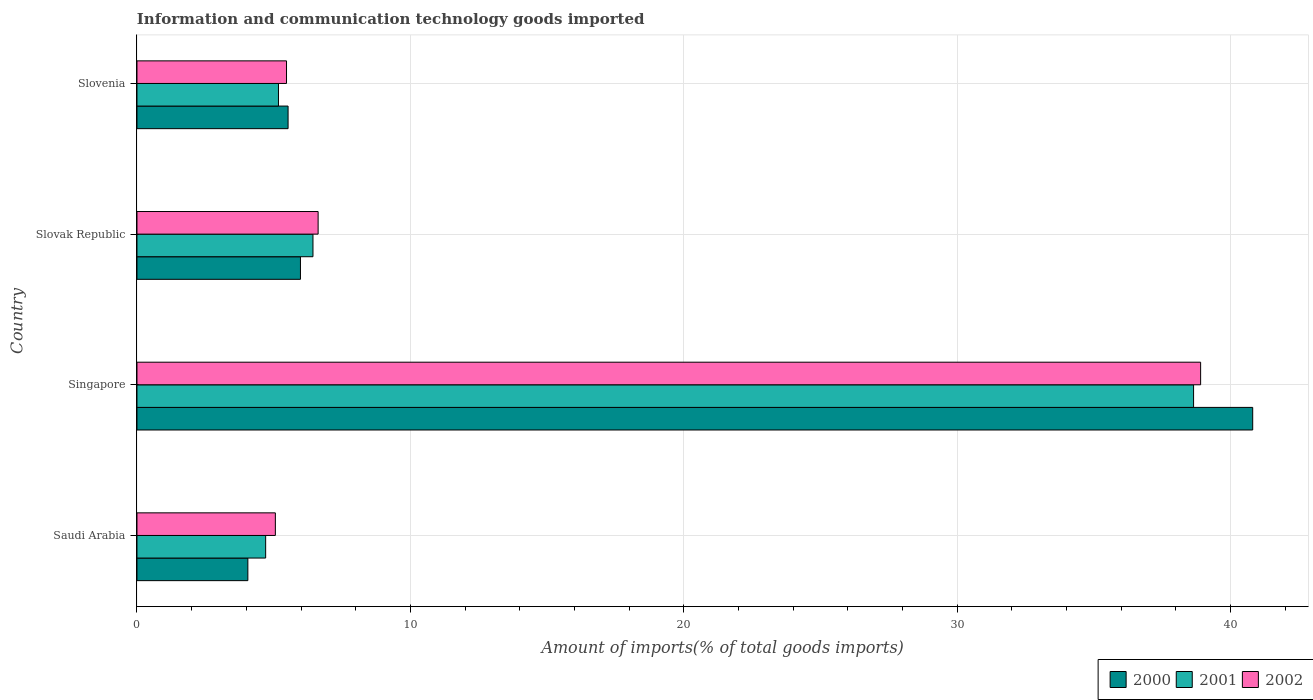How many different coloured bars are there?
Your answer should be very brief. 3. Are the number of bars per tick equal to the number of legend labels?
Ensure brevity in your answer.  Yes. Are the number of bars on each tick of the Y-axis equal?
Ensure brevity in your answer.  Yes. How many bars are there on the 3rd tick from the top?
Keep it short and to the point. 3. How many bars are there on the 3rd tick from the bottom?
Give a very brief answer. 3. What is the label of the 3rd group of bars from the top?
Offer a terse response. Singapore. In how many cases, is the number of bars for a given country not equal to the number of legend labels?
Offer a terse response. 0. What is the amount of goods imported in 2001 in Slovenia?
Offer a terse response. 5.18. Across all countries, what is the maximum amount of goods imported in 2001?
Offer a very short reply. 38.64. Across all countries, what is the minimum amount of goods imported in 2000?
Keep it short and to the point. 4.06. In which country was the amount of goods imported in 2002 maximum?
Ensure brevity in your answer.  Singapore. In which country was the amount of goods imported in 2000 minimum?
Your answer should be very brief. Saudi Arabia. What is the total amount of goods imported in 2001 in the graph?
Your answer should be compact. 54.96. What is the difference between the amount of goods imported in 2002 in Saudi Arabia and that in Slovenia?
Ensure brevity in your answer.  -0.41. What is the difference between the amount of goods imported in 2002 in Slovak Republic and the amount of goods imported in 2000 in Slovenia?
Give a very brief answer. 1.1. What is the average amount of goods imported in 2000 per country?
Ensure brevity in your answer.  14.09. What is the difference between the amount of goods imported in 2002 and amount of goods imported in 2001 in Saudi Arabia?
Keep it short and to the point. 0.36. What is the ratio of the amount of goods imported in 2000 in Singapore to that in Slovenia?
Provide a succinct answer. 7.38. Is the amount of goods imported in 2000 in Singapore less than that in Slovenia?
Provide a succinct answer. No. What is the difference between the highest and the second highest amount of goods imported in 2000?
Offer a very short reply. 34.83. What is the difference between the highest and the lowest amount of goods imported in 2001?
Your response must be concise. 33.94. What does the 3rd bar from the bottom in Slovak Republic represents?
Provide a succinct answer. 2002. Is it the case that in every country, the sum of the amount of goods imported in 2000 and amount of goods imported in 2001 is greater than the amount of goods imported in 2002?
Give a very brief answer. Yes. Are all the bars in the graph horizontal?
Offer a very short reply. Yes. How many countries are there in the graph?
Provide a short and direct response. 4. What is the difference between two consecutive major ticks on the X-axis?
Your response must be concise. 10. Are the values on the major ticks of X-axis written in scientific E-notation?
Your response must be concise. No. Does the graph contain any zero values?
Your answer should be very brief. No. Where does the legend appear in the graph?
Your answer should be very brief. Bottom right. How are the legend labels stacked?
Provide a short and direct response. Horizontal. What is the title of the graph?
Offer a terse response. Information and communication technology goods imported. Does "1970" appear as one of the legend labels in the graph?
Offer a very short reply. No. What is the label or title of the X-axis?
Your answer should be very brief. Amount of imports(% of total goods imports). What is the label or title of the Y-axis?
Your answer should be compact. Country. What is the Amount of imports(% of total goods imports) in 2000 in Saudi Arabia?
Your answer should be very brief. 4.06. What is the Amount of imports(% of total goods imports) of 2001 in Saudi Arabia?
Your answer should be very brief. 4.71. What is the Amount of imports(% of total goods imports) of 2002 in Saudi Arabia?
Your response must be concise. 5.06. What is the Amount of imports(% of total goods imports) in 2000 in Singapore?
Your answer should be compact. 40.81. What is the Amount of imports(% of total goods imports) in 2001 in Singapore?
Your answer should be very brief. 38.64. What is the Amount of imports(% of total goods imports) of 2002 in Singapore?
Make the answer very short. 38.9. What is the Amount of imports(% of total goods imports) in 2000 in Slovak Republic?
Offer a terse response. 5.98. What is the Amount of imports(% of total goods imports) in 2001 in Slovak Republic?
Offer a terse response. 6.44. What is the Amount of imports(% of total goods imports) in 2002 in Slovak Republic?
Offer a terse response. 6.63. What is the Amount of imports(% of total goods imports) of 2000 in Slovenia?
Make the answer very short. 5.53. What is the Amount of imports(% of total goods imports) in 2001 in Slovenia?
Ensure brevity in your answer.  5.18. What is the Amount of imports(% of total goods imports) in 2002 in Slovenia?
Provide a succinct answer. 5.47. Across all countries, what is the maximum Amount of imports(% of total goods imports) in 2000?
Provide a short and direct response. 40.81. Across all countries, what is the maximum Amount of imports(% of total goods imports) of 2001?
Make the answer very short. 38.64. Across all countries, what is the maximum Amount of imports(% of total goods imports) of 2002?
Give a very brief answer. 38.9. Across all countries, what is the minimum Amount of imports(% of total goods imports) of 2000?
Provide a short and direct response. 4.06. Across all countries, what is the minimum Amount of imports(% of total goods imports) of 2001?
Your answer should be very brief. 4.71. Across all countries, what is the minimum Amount of imports(% of total goods imports) of 2002?
Provide a short and direct response. 5.06. What is the total Amount of imports(% of total goods imports) of 2000 in the graph?
Ensure brevity in your answer.  56.37. What is the total Amount of imports(% of total goods imports) in 2001 in the graph?
Your answer should be compact. 54.96. What is the total Amount of imports(% of total goods imports) of 2002 in the graph?
Keep it short and to the point. 56.06. What is the difference between the Amount of imports(% of total goods imports) of 2000 in Saudi Arabia and that in Singapore?
Your answer should be very brief. -36.75. What is the difference between the Amount of imports(% of total goods imports) of 2001 in Saudi Arabia and that in Singapore?
Give a very brief answer. -33.94. What is the difference between the Amount of imports(% of total goods imports) of 2002 in Saudi Arabia and that in Singapore?
Offer a terse response. -33.84. What is the difference between the Amount of imports(% of total goods imports) of 2000 in Saudi Arabia and that in Slovak Republic?
Offer a very short reply. -1.92. What is the difference between the Amount of imports(% of total goods imports) of 2001 in Saudi Arabia and that in Slovak Republic?
Ensure brevity in your answer.  -1.73. What is the difference between the Amount of imports(% of total goods imports) in 2002 in Saudi Arabia and that in Slovak Republic?
Provide a short and direct response. -1.56. What is the difference between the Amount of imports(% of total goods imports) of 2000 in Saudi Arabia and that in Slovenia?
Keep it short and to the point. -1.47. What is the difference between the Amount of imports(% of total goods imports) in 2001 in Saudi Arabia and that in Slovenia?
Make the answer very short. -0.47. What is the difference between the Amount of imports(% of total goods imports) of 2002 in Saudi Arabia and that in Slovenia?
Offer a very short reply. -0.41. What is the difference between the Amount of imports(% of total goods imports) of 2000 in Singapore and that in Slovak Republic?
Provide a short and direct response. 34.83. What is the difference between the Amount of imports(% of total goods imports) in 2001 in Singapore and that in Slovak Republic?
Your answer should be compact. 32.21. What is the difference between the Amount of imports(% of total goods imports) in 2002 in Singapore and that in Slovak Republic?
Your answer should be compact. 32.28. What is the difference between the Amount of imports(% of total goods imports) of 2000 in Singapore and that in Slovenia?
Provide a short and direct response. 35.28. What is the difference between the Amount of imports(% of total goods imports) of 2001 in Singapore and that in Slovenia?
Provide a succinct answer. 33.47. What is the difference between the Amount of imports(% of total goods imports) in 2002 in Singapore and that in Slovenia?
Make the answer very short. 33.43. What is the difference between the Amount of imports(% of total goods imports) of 2000 in Slovak Republic and that in Slovenia?
Ensure brevity in your answer.  0.45. What is the difference between the Amount of imports(% of total goods imports) in 2001 in Slovak Republic and that in Slovenia?
Provide a succinct answer. 1.26. What is the difference between the Amount of imports(% of total goods imports) in 2002 in Slovak Republic and that in Slovenia?
Your answer should be compact. 1.16. What is the difference between the Amount of imports(% of total goods imports) in 2000 in Saudi Arabia and the Amount of imports(% of total goods imports) in 2001 in Singapore?
Offer a terse response. -34.59. What is the difference between the Amount of imports(% of total goods imports) of 2000 in Saudi Arabia and the Amount of imports(% of total goods imports) of 2002 in Singapore?
Make the answer very short. -34.85. What is the difference between the Amount of imports(% of total goods imports) of 2001 in Saudi Arabia and the Amount of imports(% of total goods imports) of 2002 in Singapore?
Give a very brief answer. -34.19. What is the difference between the Amount of imports(% of total goods imports) in 2000 in Saudi Arabia and the Amount of imports(% of total goods imports) in 2001 in Slovak Republic?
Offer a terse response. -2.38. What is the difference between the Amount of imports(% of total goods imports) of 2000 in Saudi Arabia and the Amount of imports(% of total goods imports) of 2002 in Slovak Republic?
Keep it short and to the point. -2.57. What is the difference between the Amount of imports(% of total goods imports) of 2001 in Saudi Arabia and the Amount of imports(% of total goods imports) of 2002 in Slovak Republic?
Ensure brevity in your answer.  -1.92. What is the difference between the Amount of imports(% of total goods imports) of 2000 in Saudi Arabia and the Amount of imports(% of total goods imports) of 2001 in Slovenia?
Your response must be concise. -1.12. What is the difference between the Amount of imports(% of total goods imports) of 2000 in Saudi Arabia and the Amount of imports(% of total goods imports) of 2002 in Slovenia?
Your answer should be compact. -1.41. What is the difference between the Amount of imports(% of total goods imports) in 2001 in Saudi Arabia and the Amount of imports(% of total goods imports) in 2002 in Slovenia?
Ensure brevity in your answer.  -0.76. What is the difference between the Amount of imports(% of total goods imports) of 2000 in Singapore and the Amount of imports(% of total goods imports) of 2001 in Slovak Republic?
Your answer should be very brief. 34.37. What is the difference between the Amount of imports(% of total goods imports) of 2000 in Singapore and the Amount of imports(% of total goods imports) of 2002 in Slovak Republic?
Keep it short and to the point. 34.18. What is the difference between the Amount of imports(% of total goods imports) of 2001 in Singapore and the Amount of imports(% of total goods imports) of 2002 in Slovak Republic?
Provide a succinct answer. 32.02. What is the difference between the Amount of imports(% of total goods imports) of 2000 in Singapore and the Amount of imports(% of total goods imports) of 2001 in Slovenia?
Keep it short and to the point. 35.63. What is the difference between the Amount of imports(% of total goods imports) of 2000 in Singapore and the Amount of imports(% of total goods imports) of 2002 in Slovenia?
Make the answer very short. 35.34. What is the difference between the Amount of imports(% of total goods imports) in 2001 in Singapore and the Amount of imports(% of total goods imports) in 2002 in Slovenia?
Give a very brief answer. 33.17. What is the difference between the Amount of imports(% of total goods imports) in 2000 in Slovak Republic and the Amount of imports(% of total goods imports) in 2001 in Slovenia?
Keep it short and to the point. 0.8. What is the difference between the Amount of imports(% of total goods imports) in 2000 in Slovak Republic and the Amount of imports(% of total goods imports) in 2002 in Slovenia?
Your response must be concise. 0.51. What is the difference between the Amount of imports(% of total goods imports) in 2001 in Slovak Republic and the Amount of imports(% of total goods imports) in 2002 in Slovenia?
Make the answer very short. 0.97. What is the average Amount of imports(% of total goods imports) in 2000 per country?
Your answer should be very brief. 14.09. What is the average Amount of imports(% of total goods imports) in 2001 per country?
Your answer should be compact. 13.74. What is the average Amount of imports(% of total goods imports) of 2002 per country?
Your answer should be very brief. 14.01. What is the difference between the Amount of imports(% of total goods imports) in 2000 and Amount of imports(% of total goods imports) in 2001 in Saudi Arabia?
Your answer should be very brief. -0.65. What is the difference between the Amount of imports(% of total goods imports) in 2000 and Amount of imports(% of total goods imports) in 2002 in Saudi Arabia?
Offer a very short reply. -1.01. What is the difference between the Amount of imports(% of total goods imports) of 2001 and Amount of imports(% of total goods imports) of 2002 in Saudi Arabia?
Give a very brief answer. -0.36. What is the difference between the Amount of imports(% of total goods imports) in 2000 and Amount of imports(% of total goods imports) in 2001 in Singapore?
Make the answer very short. 2.16. What is the difference between the Amount of imports(% of total goods imports) of 2000 and Amount of imports(% of total goods imports) of 2002 in Singapore?
Make the answer very short. 1.9. What is the difference between the Amount of imports(% of total goods imports) of 2001 and Amount of imports(% of total goods imports) of 2002 in Singapore?
Your response must be concise. -0.26. What is the difference between the Amount of imports(% of total goods imports) in 2000 and Amount of imports(% of total goods imports) in 2001 in Slovak Republic?
Offer a terse response. -0.46. What is the difference between the Amount of imports(% of total goods imports) of 2000 and Amount of imports(% of total goods imports) of 2002 in Slovak Republic?
Your response must be concise. -0.65. What is the difference between the Amount of imports(% of total goods imports) in 2001 and Amount of imports(% of total goods imports) in 2002 in Slovak Republic?
Make the answer very short. -0.19. What is the difference between the Amount of imports(% of total goods imports) in 2000 and Amount of imports(% of total goods imports) in 2001 in Slovenia?
Ensure brevity in your answer.  0.35. What is the difference between the Amount of imports(% of total goods imports) of 2000 and Amount of imports(% of total goods imports) of 2002 in Slovenia?
Make the answer very short. 0.06. What is the difference between the Amount of imports(% of total goods imports) of 2001 and Amount of imports(% of total goods imports) of 2002 in Slovenia?
Make the answer very short. -0.29. What is the ratio of the Amount of imports(% of total goods imports) of 2000 in Saudi Arabia to that in Singapore?
Your answer should be compact. 0.1. What is the ratio of the Amount of imports(% of total goods imports) of 2001 in Saudi Arabia to that in Singapore?
Provide a succinct answer. 0.12. What is the ratio of the Amount of imports(% of total goods imports) of 2002 in Saudi Arabia to that in Singapore?
Provide a short and direct response. 0.13. What is the ratio of the Amount of imports(% of total goods imports) of 2000 in Saudi Arabia to that in Slovak Republic?
Provide a short and direct response. 0.68. What is the ratio of the Amount of imports(% of total goods imports) in 2001 in Saudi Arabia to that in Slovak Republic?
Provide a short and direct response. 0.73. What is the ratio of the Amount of imports(% of total goods imports) of 2002 in Saudi Arabia to that in Slovak Republic?
Provide a short and direct response. 0.76. What is the ratio of the Amount of imports(% of total goods imports) in 2000 in Saudi Arabia to that in Slovenia?
Give a very brief answer. 0.73. What is the ratio of the Amount of imports(% of total goods imports) in 2001 in Saudi Arabia to that in Slovenia?
Give a very brief answer. 0.91. What is the ratio of the Amount of imports(% of total goods imports) of 2002 in Saudi Arabia to that in Slovenia?
Offer a terse response. 0.93. What is the ratio of the Amount of imports(% of total goods imports) of 2000 in Singapore to that in Slovak Republic?
Keep it short and to the point. 6.82. What is the ratio of the Amount of imports(% of total goods imports) in 2001 in Singapore to that in Slovak Republic?
Your answer should be compact. 6. What is the ratio of the Amount of imports(% of total goods imports) of 2002 in Singapore to that in Slovak Republic?
Keep it short and to the point. 5.87. What is the ratio of the Amount of imports(% of total goods imports) of 2000 in Singapore to that in Slovenia?
Ensure brevity in your answer.  7.38. What is the ratio of the Amount of imports(% of total goods imports) in 2001 in Singapore to that in Slovenia?
Provide a succinct answer. 7.47. What is the ratio of the Amount of imports(% of total goods imports) in 2002 in Singapore to that in Slovenia?
Offer a very short reply. 7.11. What is the ratio of the Amount of imports(% of total goods imports) of 2000 in Slovak Republic to that in Slovenia?
Offer a terse response. 1.08. What is the ratio of the Amount of imports(% of total goods imports) in 2001 in Slovak Republic to that in Slovenia?
Provide a succinct answer. 1.24. What is the ratio of the Amount of imports(% of total goods imports) of 2002 in Slovak Republic to that in Slovenia?
Ensure brevity in your answer.  1.21. What is the difference between the highest and the second highest Amount of imports(% of total goods imports) in 2000?
Offer a terse response. 34.83. What is the difference between the highest and the second highest Amount of imports(% of total goods imports) of 2001?
Offer a very short reply. 32.21. What is the difference between the highest and the second highest Amount of imports(% of total goods imports) in 2002?
Give a very brief answer. 32.28. What is the difference between the highest and the lowest Amount of imports(% of total goods imports) of 2000?
Your answer should be compact. 36.75. What is the difference between the highest and the lowest Amount of imports(% of total goods imports) of 2001?
Provide a succinct answer. 33.94. What is the difference between the highest and the lowest Amount of imports(% of total goods imports) in 2002?
Your answer should be very brief. 33.84. 